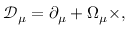Convert formula to latex. <formula><loc_0><loc_0><loc_500><loc_500>{ \mathcal { D } } _ { \mu } = \partial _ { \mu } + \Omega _ { \mu } \times ,</formula> 